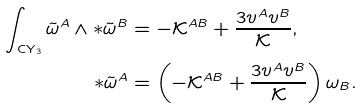Convert formula to latex. <formula><loc_0><loc_0><loc_500><loc_500>\int _ { \text {CY} _ { 3 } } \tilde { \omega } ^ { A } \wedge * \tilde { \omega } ^ { B } & = - \mathcal { K } ^ { A B } + \frac { 3 v ^ { A } v ^ { B } } { \mathcal { K } } , \\ * \tilde { \omega } ^ { A } & = \left ( - \mathcal { K } ^ { A B } + \frac { 3 v ^ { A } v ^ { B } } { \mathcal { K } } \right ) \omega _ { B } .</formula> 